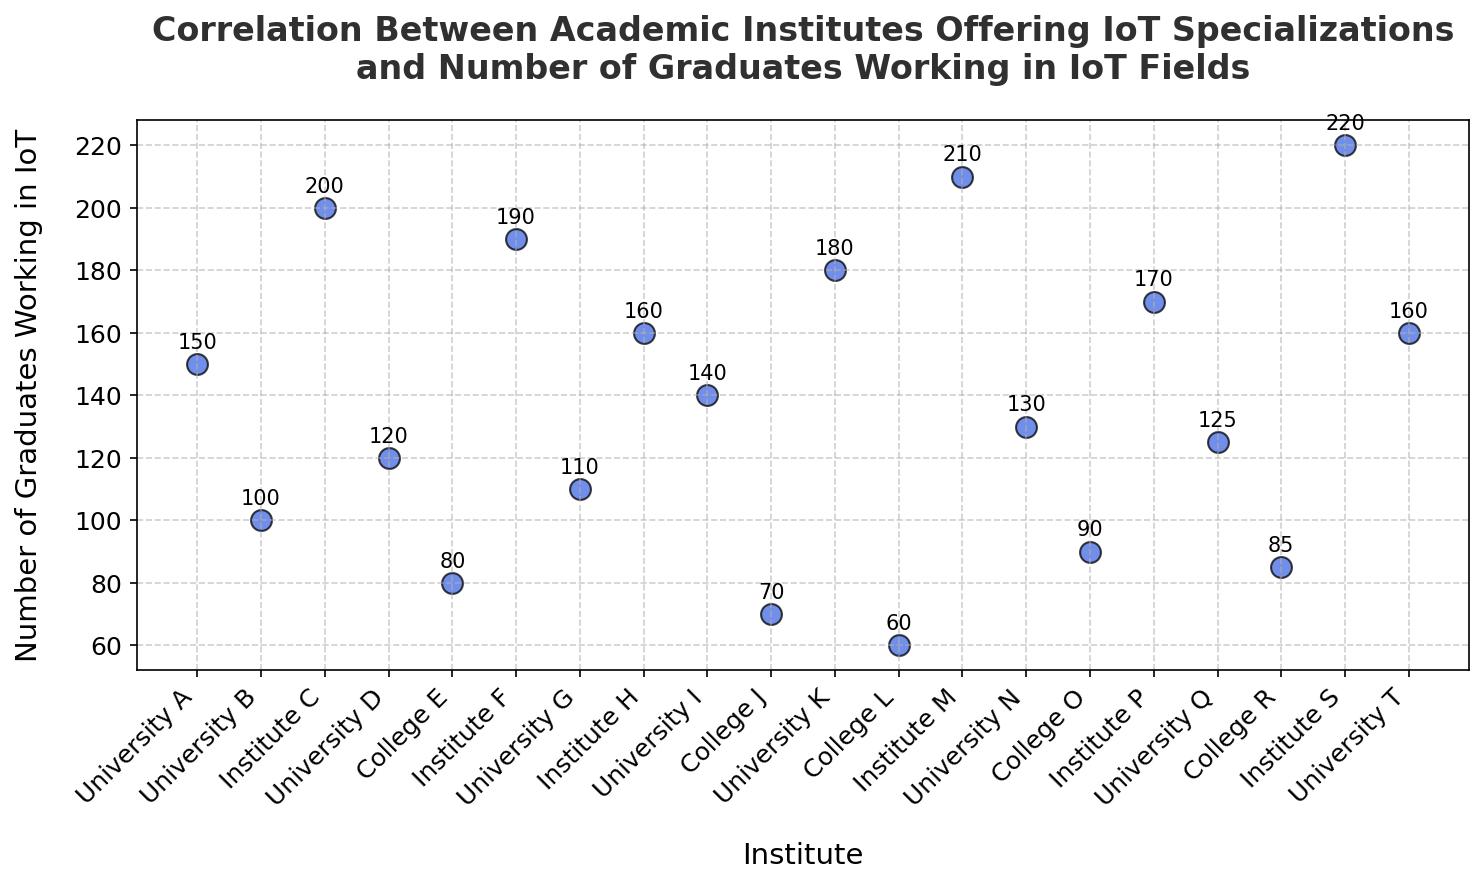Which academic institute has the highest number of graduates working in IoT fields? The highest number of graduates working in IoT fields can be determined by finding the institute with the maximum value on the y-axis.
Answer: Institute S What is the sum of graduates in IoT fields from University A and Institute S? Add the number of graduates from University A (150) and Institute S (220). So, 150 + 220 = 370
Answer: 370 Which has more graduates working in IoT fields, University K or Institute F? Compare the y-axis values for University K (180) and Institute F (190). Institute F has more graduates by 10.
Answer: Institute F Which institute has fewer graduates working in IoT fields, College E, or College J? Compare the y-axis values for College E (80) and College J (70). College J has fewer graduates by 10.
Answer: College J Estimate the average number of graduates working in IoT fields for institutes labeled as universities. Sum the graduates from all universities (A:150, B:100, D:120, G:110, I:140, K:180, N:130, Q:125, T:160) and divide by the number of universities (9). The sum is 1215, so the average is 1215/9 ≈ 135
Answer: 135 What is the difference between the number of graduates working in IoT fields from Institute M and College L? Subtract the number of graduates from College L (60) from Institute M (210). So, 210 - 60 = 150
Answer: 150 Do any two institutes have the same number of graduates working in IoT fields? By visually inspecting the scatter plot, we see University T and Institute H both have 160 graduates.
Answer: Yes Which is more common among the institutes offering IoT specializations, having more than 150 graduates or fewer? Count the institutes with more than 150 graduates (University A, Institute F, Institute H, University K, Institute M, Institute P, Institute S, University T: 8 institutes) and those with fewer (University B, University D, College E, University G, University I, College J, College L, University N, College O, College R: 10 institutes). There are more institutes with fewer than 150 graduates.
Answer: Fewer Identify the institute with the median number of graduates working in IoT. List all the graduate counts, sort them, and find the middle value. The values are [60, 70, 80, 85, 90, 100, 110, 120, 125, 130, 140, 150, 160, 160, 170, 180, 190, 200, 210, 220]. The median (middle) values are between the 10th and 11th values: (130 + 140)/2 = 135. The closest institute to this value is University I with 140.
Answer: University I 